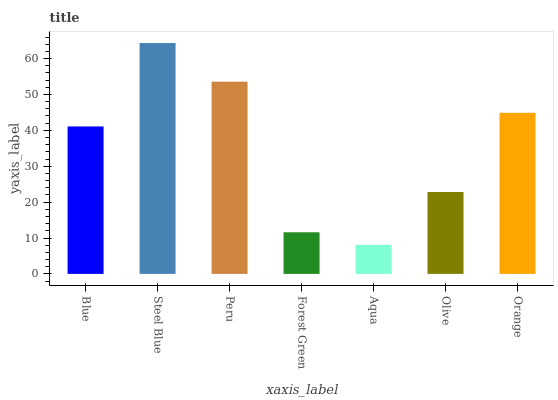Is Peru the minimum?
Answer yes or no. No. Is Peru the maximum?
Answer yes or no. No. Is Steel Blue greater than Peru?
Answer yes or no. Yes. Is Peru less than Steel Blue?
Answer yes or no. Yes. Is Peru greater than Steel Blue?
Answer yes or no. No. Is Steel Blue less than Peru?
Answer yes or no. No. Is Blue the high median?
Answer yes or no. Yes. Is Blue the low median?
Answer yes or no. Yes. Is Orange the high median?
Answer yes or no. No. Is Forest Green the low median?
Answer yes or no. No. 